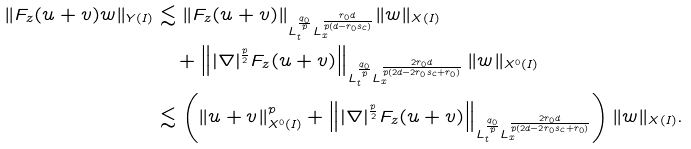Convert formula to latex. <formula><loc_0><loc_0><loc_500><loc_500>\| F _ { z } ( u + v ) w \| _ { Y ( I ) } & \lesssim \| F _ { z } ( u + v ) \| _ { L _ { t } ^ { \frac { q _ { 0 } } p } L _ { x } ^ { \frac { r _ { 0 } d } { p ( d - r _ { 0 } s _ { c } ) } } } \| w \| _ { X ( I ) } \\ & \quad + \left \| | \nabla | ^ { \frac { p } { 2 } } F _ { z } ( u + v ) \right \| _ { L _ { t } ^ { \frac { q _ { 0 } } p } L _ { x } ^ { \frac { 2 r _ { 0 } d } { p ( 2 d - 2 r _ { 0 } s _ { c } + r _ { 0 } ) } } } \| w \| _ { X ^ { 0 } ( I ) } \\ & \lesssim \left ( \| u + v \| _ { X ^ { 0 } ( I ) } ^ { p } + \left \| | \nabla | ^ { \frac { p } { 2 } } F _ { z } ( u + v ) \right \| _ { L _ { t } ^ { \frac { q _ { 0 } } p } L _ { x } ^ { \frac { 2 r _ { 0 } d } { p ( 2 d - 2 r _ { 0 } s _ { c } + r _ { 0 } ) } } } \right ) \| w \| _ { X ( I ) } .</formula> 